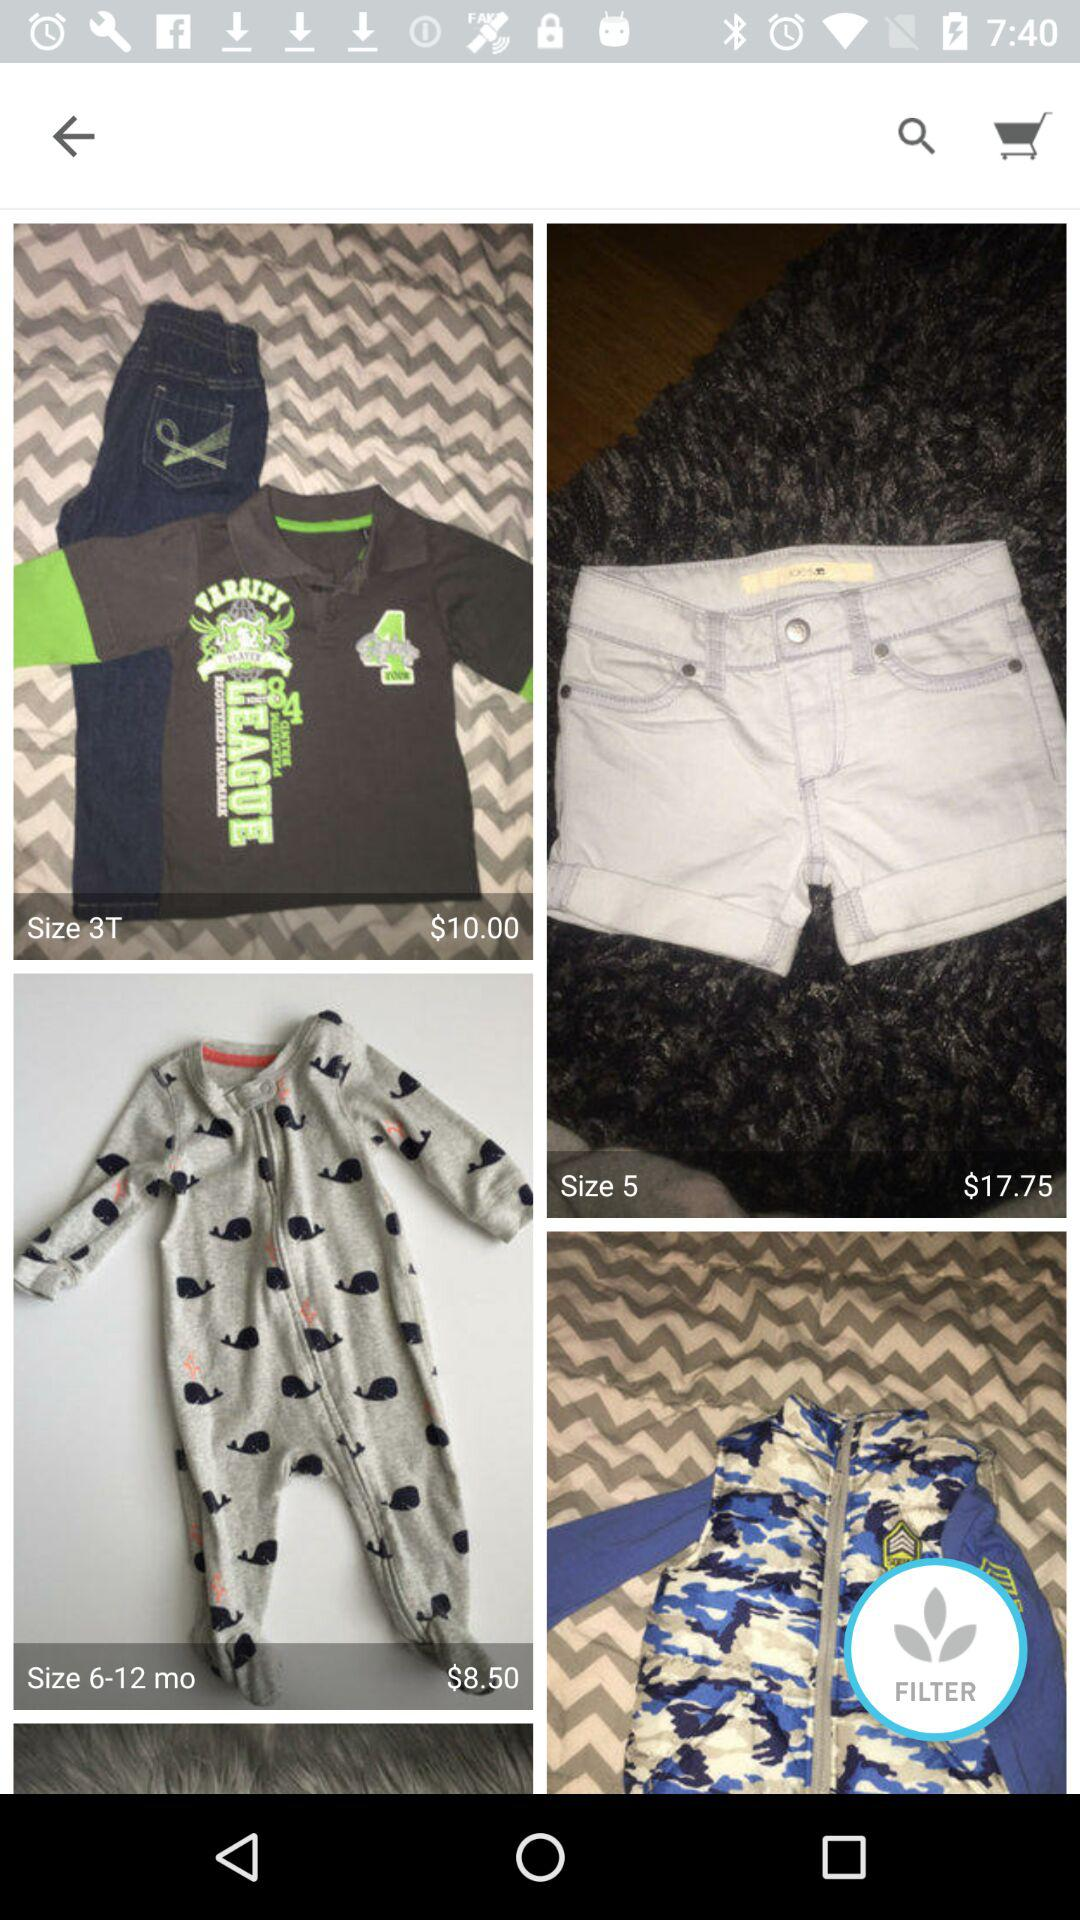How many items have a price that is less than $15?
Answer the question using a single word or phrase. 2 